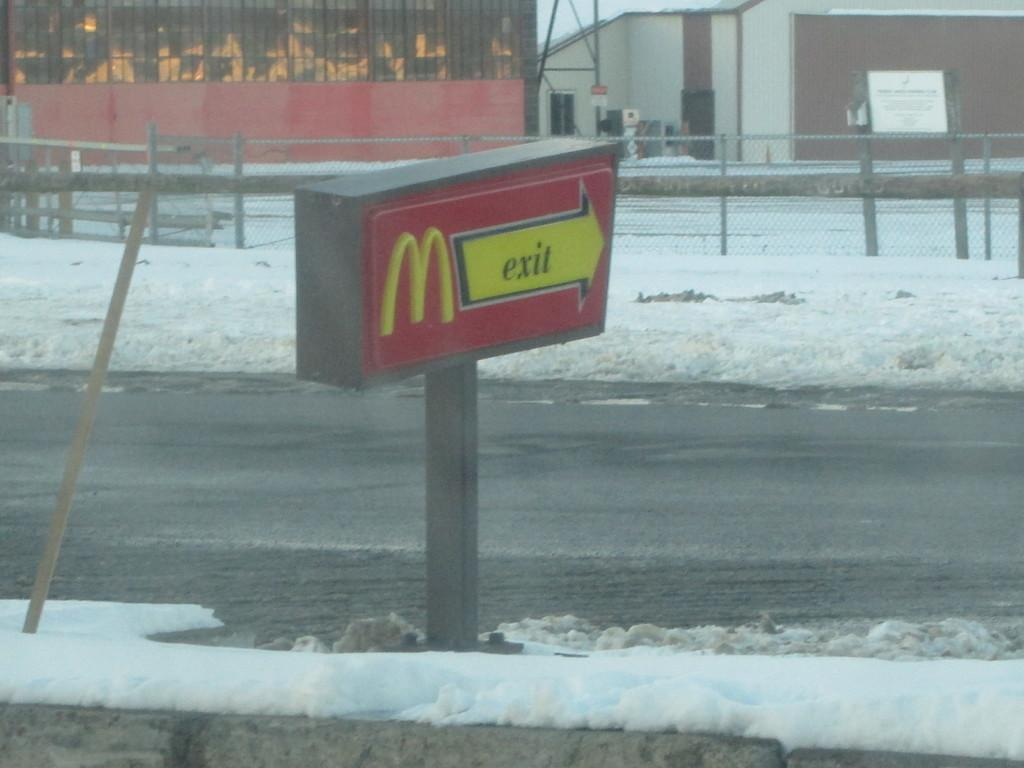<image>
Create a compact narrative representing the image presented. A McDonald's sign that points the way to the exit. 